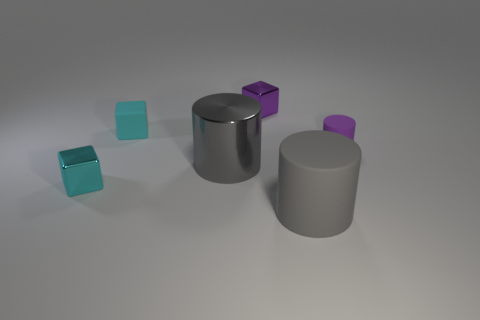Do the big metallic thing and the big rubber cylinder have the same color?
Give a very brief answer. Yes. There is a big gray object to the left of the small purple block that is behind the small purple matte cylinder; what number of small matte things are right of it?
Provide a succinct answer. 1. There is a thing to the right of the gray cylinder that is right of the small cube that is behind the small rubber cube; what is its shape?
Offer a very short reply. Cylinder. How many other objects are there of the same color as the metallic cylinder?
Your answer should be very brief. 1. There is a large gray object that is right of the big cylinder that is on the left side of the large gray matte cylinder; what is its shape?
Your answer should be very brief. Cylinder. What number of matte cubes are in front of the tiny cylinder?
Provide a succinct answer. 0. Are there any yellow balls that have the same material as the small purple cylinder?
Offer a terse response. No. What is the material of the cylinder that is the same size as the gray metallic thing?
Provide a succinct answer. Rubber. What is the size of the object that is both on the left side of the large gray shiny cylinder and in front of the purple matte cylinder?
Provide a succinct answer. Small. The thing that is in front of the large metallic object and to the right of the gray metal object is what color?
Your answer should be compact. Gray. 